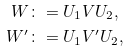<formula> <loc_0><loc_0><loc_500><loc_500>W & \colon = U _ { 1 } V U _ { 2 } , \\ W ^ { \prime } & \colon = U _ { 1 } V ^ { \prime } U _ { 2 } ,</formula> 